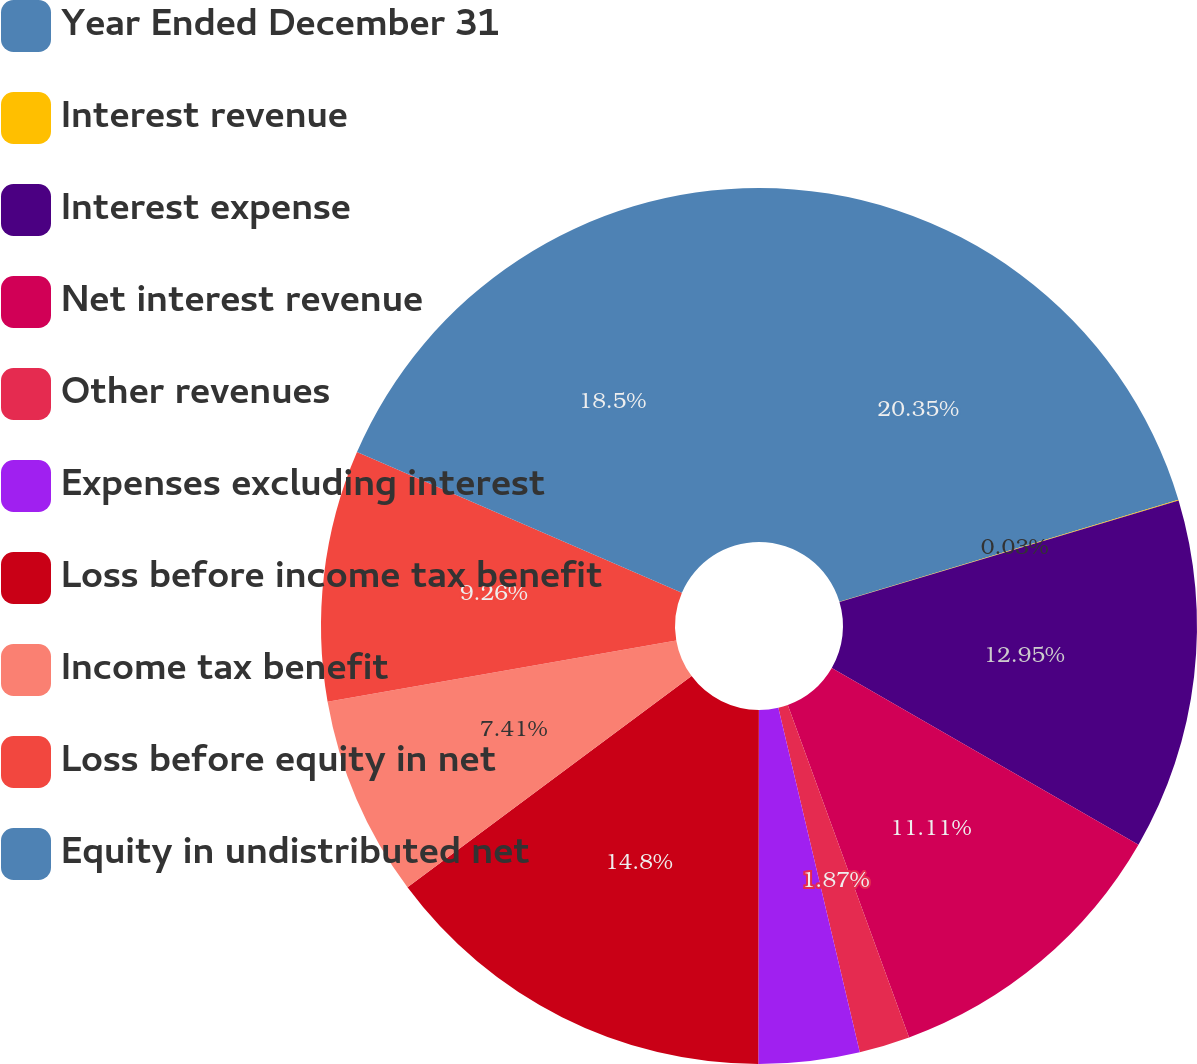Convert chart to OTSL. <chart><loc_0><loc_0><loc_500><loc_500><pie_chart><fcel>Year Ended December 31<fcel>Interest revenue<fcel>Interest expense<fcel>Net interest revenue<fcel>Other revenues<fcel>Expenses excluding interest<fcel>Loss before income tax benefit<fcel>Income tax benefit<fcel>Loss before equity in net<fcel>Equity in undistributed net<nl><fcel>20.34%<fcel>0.03%<fcel>12.95%<fcel>11.11%<fcel>1.87%<fcel>3.72%<fcel>14.8%<fcel>7.41%<fcel>9.26%<fcel>18.5%<nl></chart> 